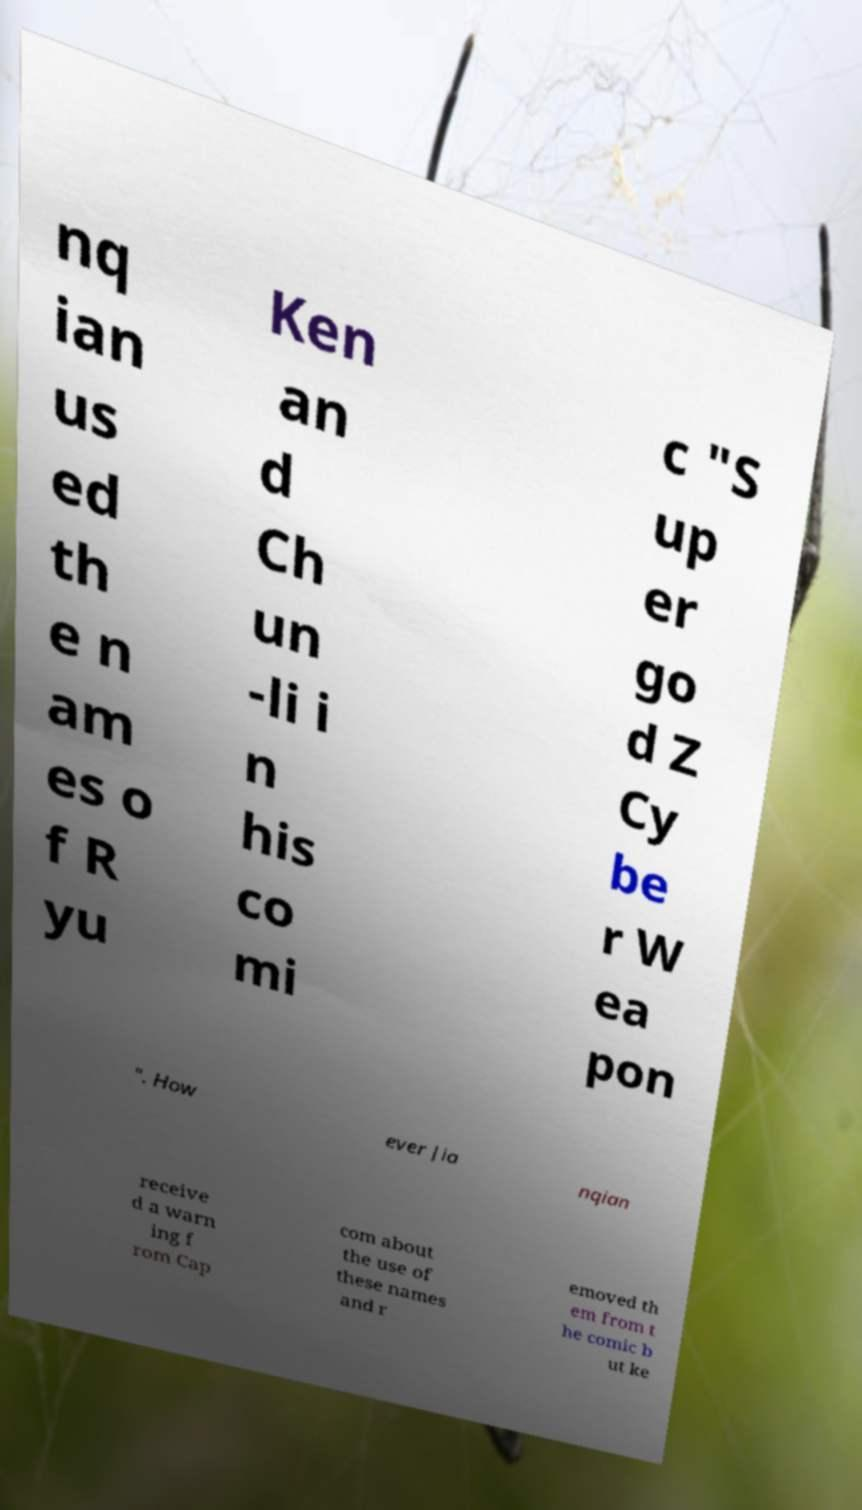Please identify and transcribe the text found in this image. nq ian us ed th e n am es o f R yu Ken an d Ch un -li i n his co mi c "S up er go d Z Cy be r W ea pon ". How ever Jia nqian receive d a warn ing f rom Cap com about the use of these names and r emoved th em from t he comic b ut ke 